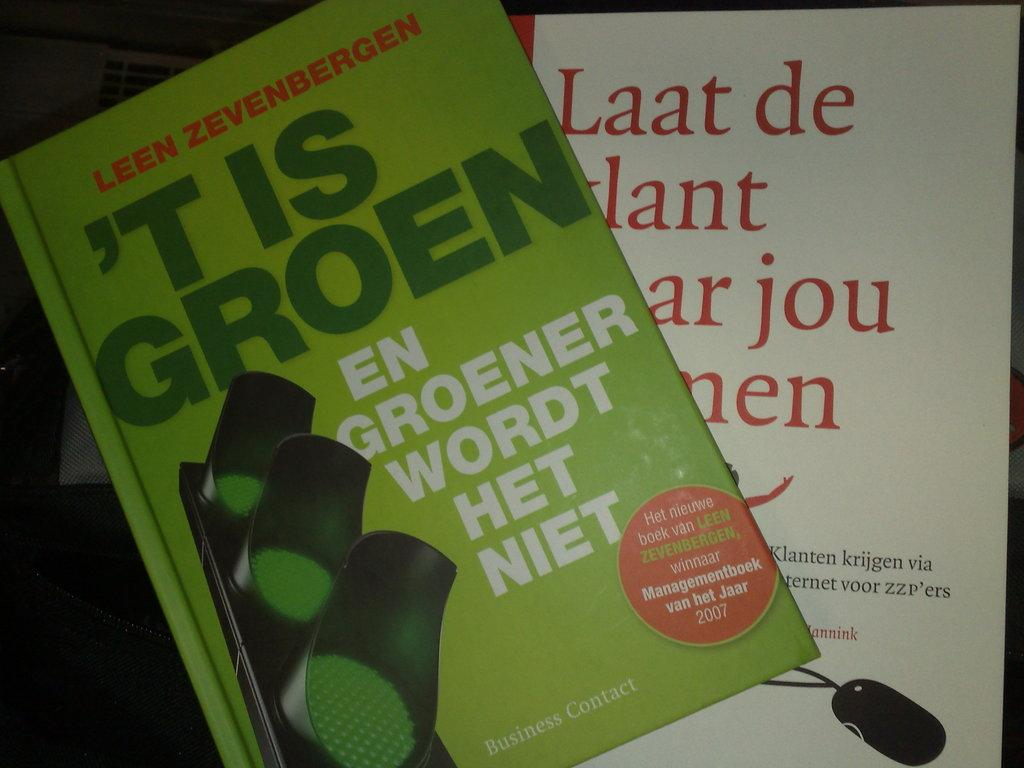Provide a one-sentence caption for the provided image. Green book by Leen Zevenbergen titled "'t Is Goren". 